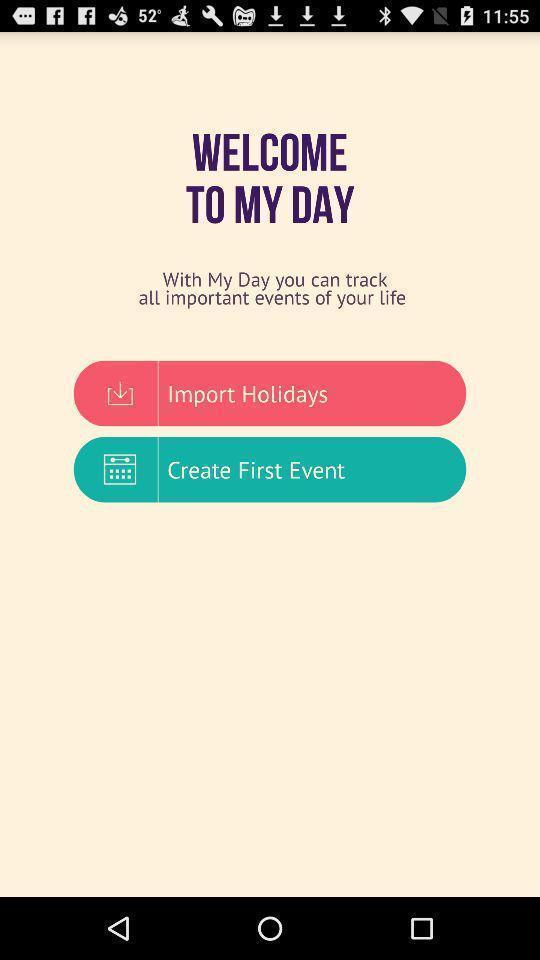Tell me what you see in this picture. Welcome page to a calendar app. 